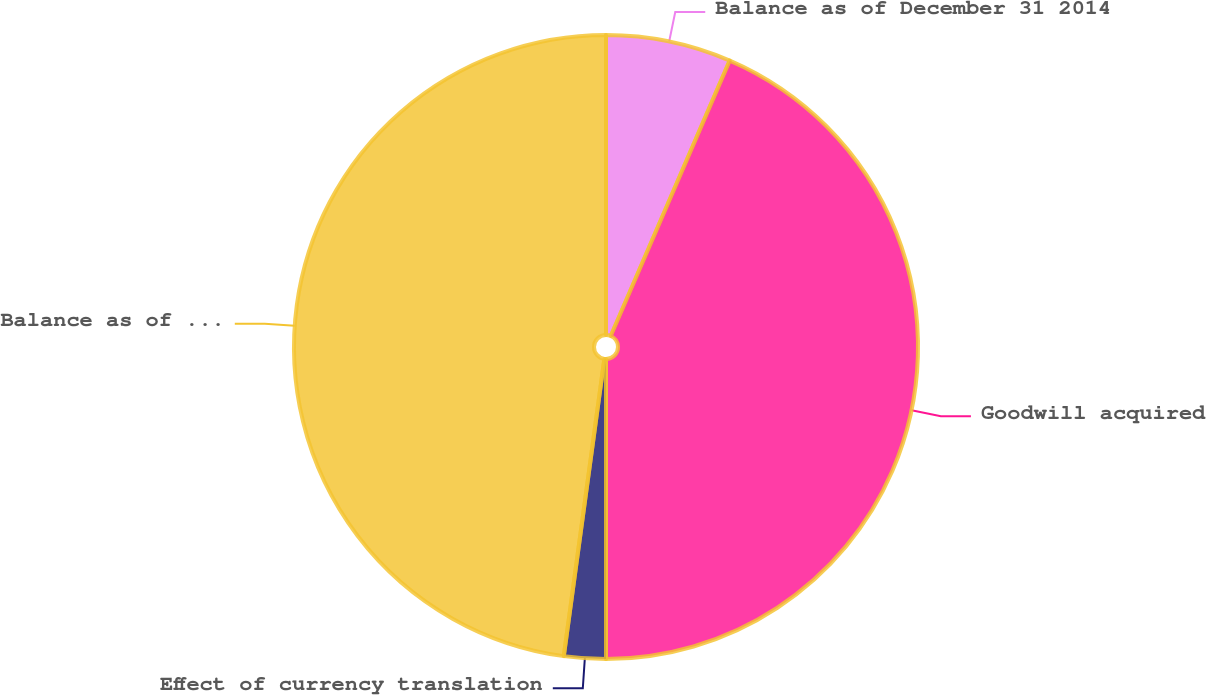Convert chart. <chart><loc_0><loc_0><loc_500><loc_500><pie_chart><fcel>Balance as of December 31 2014<fcel>Goodwill acquired<fcel>Effect of currency translation<fcel>Balance as of December 31 2015<nl><fcel>6.49%<fcel>43.51%<fcel>2.16%<fcel>47.84%<nl></chart> 